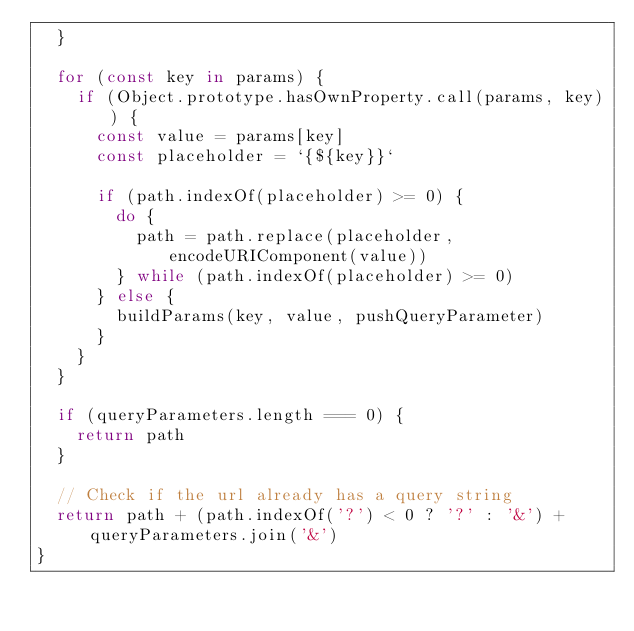<code> <loc_0><loc_0><loc_500><loc_500><_JavaScript_>  }

  for (const key in params) {
    if (Object.prototype.hasOwnProperty.call(params, key)) {
      const value = params[key]
      const placeholder = `{${key}}`

      if (path.indexOf(placeholder) >= 0) {
        do {
          path = path.replace(placeholder, encodeURIComponent(value))
        } while (path.indexOf(placeholder) >= 0)
      } else {
        buildParams(key, value, pushQueryParameter)
      }
    }
  }

  if (queryParameters.length === 0) {
    return path
  }

  // Check if the url already has a query string
  return path + (path.indexOf('?') < 0 ? '?' : '&') + queryParameters.join('&')
}
</code> 